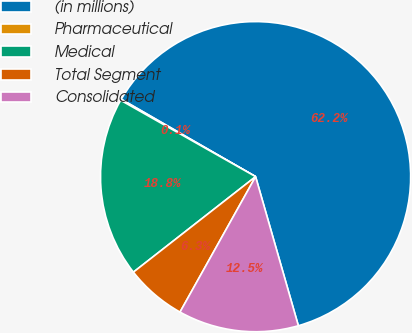<chart> <loc_0><loc_0><loc_500><loc_500><pie_chart><fcel>(in millions)<fcel>Pharmaceutical<fcel>Medical<fcel>Total Segment<fcel>Consolidated<nl><fcel>62.24%<fcel>0.12%<fcel>18.76%<fcel>6.34%<fcel>12.55%<nl></chart> 